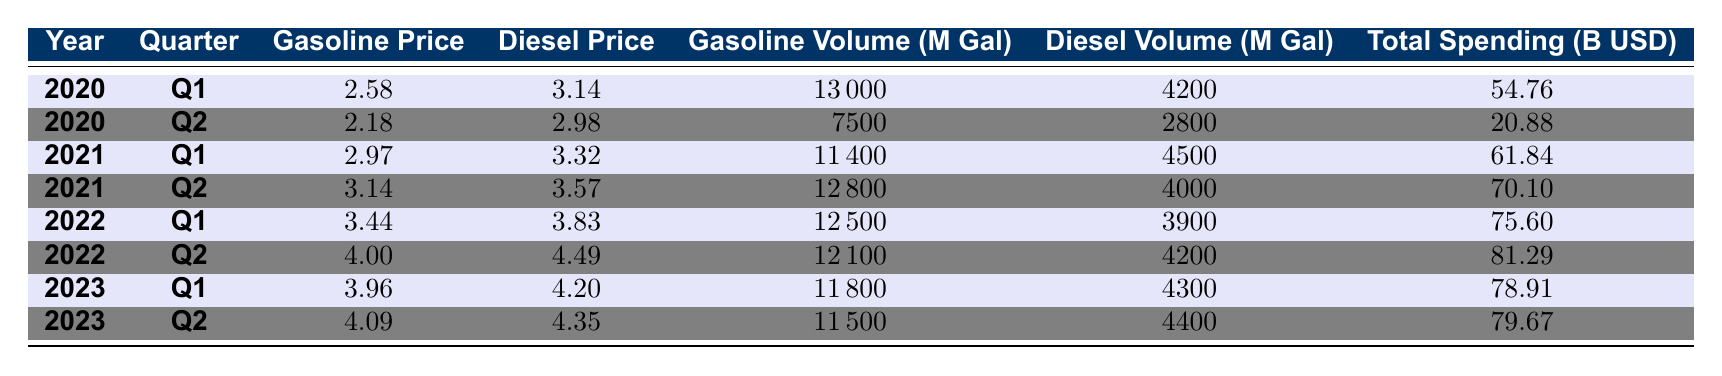What was the gasoline price in Q2 of 2021? The table shows that in Q2 of 2021, the gasoline price was listed as 3.14.
Answer: 3.14 What was the total consumer spending in Q1 of 2022? According to the table, the total consumer spending in Q1 of 2022 is 75.60 billion USD.
Answer: 75.60 billion USD What was the difference in gasoline volume consumed between Q1 2020 and Q2 2020? In Q1 2020, the gasoline volume consumed was 13000 million gallons, and in Q2 2020 it was 7500 million gallons. The difference is 13000 - 7500 = 5500 million gallons.
Answer: 5500 million gallons What is the average diesel price from Q1 2022 to Q2 2023? To find the average diesel price, we take the diesel prices for Q1 2022 (3.83), Q2 2022 (4.49), Q1 2023 (4.20), and Q2 2023 (4.35). The average is (3.83 + 4.49 + 4.20 + 4.35) / 4 = 4.1725, rounded to 4.17.
Answer: 4.17 Did consumer spending increase from Q2 2020 to Q1 2021? In Q2 2020, total consumer spending was 20.88 billion USD, and in Q1 2021 it increased to 61.84 billion USD. Therefore, consumer spending did increase.
Answer: Yes What was the total volume of gasoline and diesel consumed in Q2 2022? In Q2 2022, the gasoline volume consumed was 12100 million gallons and the diesel volume was 4200 million gallons. Summing these gives 12100 + 4200 = 16300 million gallons.
Answer: 16300 million gallons What is the highest gasoline price recorded in the table? The highest gasoline price indicated in the table is 4.09 in Q2 of 2023.
Answer: 4.09 How did the total consumer spending in Q2 of 2023 compare to Q1 of 2023? In Q2 2023, total consumer spending was 79.67 billion USD, which is higher than Q1 2023's spending of 78.91 billion USD. The difference is 79.67 - 78.91 = 0.76 billion USD.
Answer: Increased by 0.76 billion USD What was the trend in diesel volume consumed from Q1 2020 to Q1 2023? The diesel volumes for Q1 2020 and Q1 2023 are 4200 million gallons and 4300 million gallons, respectively. The trend shows a slight increase of 100 million gallons over this period.
Answer: Increased by 100 million gallons Was there a decrease in the gasoline consumption volume from Q1 2021 to Q2 2021? Yes, Q1 2021 saw a consumption of 11400 million gallons and Q2 2021 saw 12800 million gallons, indicating an increase, not a decrease.
Answer: No 